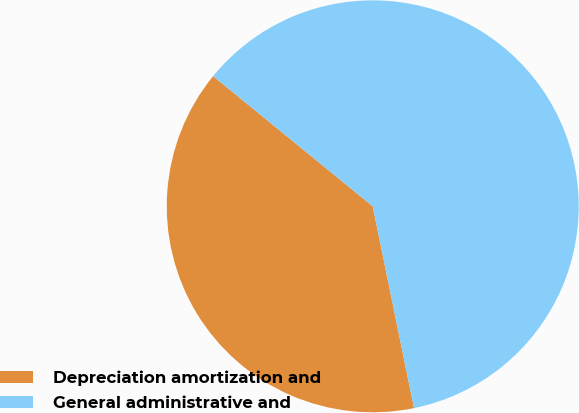<chart> <loc_0><loc_0><loc_500><loc_500><pie_chart><fcel>Depreciation amortization and<fcel>General administrative and<nl><fcel>39.1%<fcel>60.9%<nl></chart> 